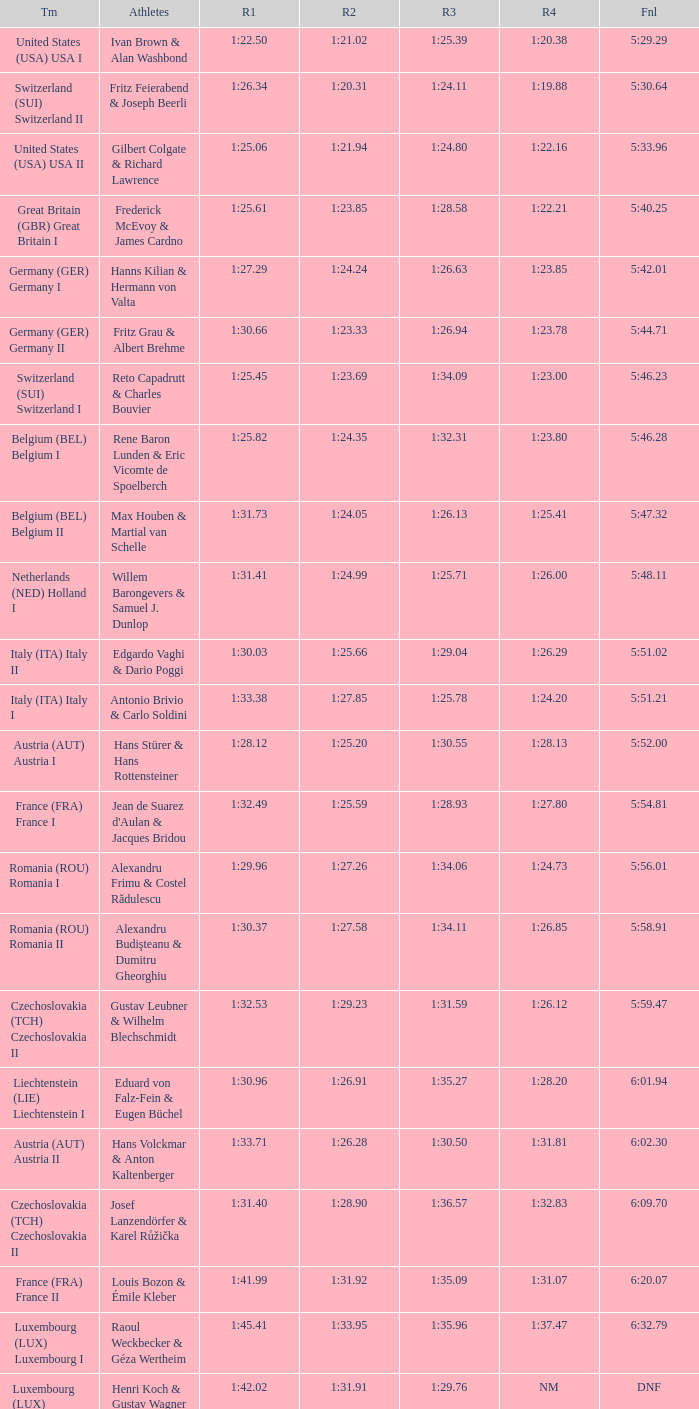Which Run 4 has Athletes of alexandru frimu & costel rădulescu? 1:24.73. 